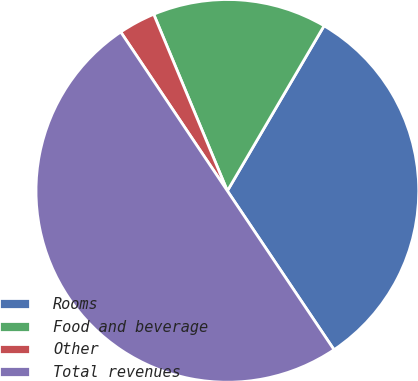Convert chart. <chart><loc_0><loc_0><loc_500><loc_500><pie_chart><fcel>Rooms<fcel>Food and beverage<fcel>Other<fcel>Total revenues<nl><fcel>32.15%<fcel>14.72%<fcel>3.12%<fcel>50.0%<nl></chart> 